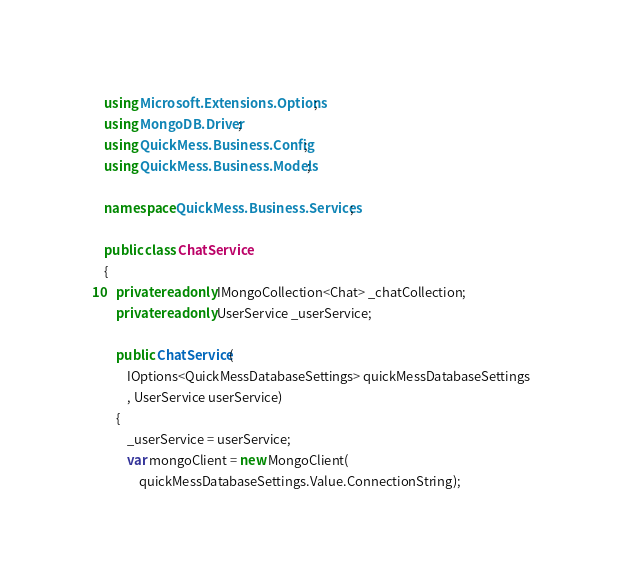Convert code to text. <code><loc_0><loc_0><loc_500><loc_500><_C#_>using Microsoft.Extensions.Options;
using MongoDB.Driver;
using QuickMess.Business.Config;
using QuickMess.Business.Models;

namespace QuickMess.Business.Services;

public class ChatService
{
    private readonly IMongoCollection<Chat> _chatCollection;
    private readonly UserService _userService;

    public ChatService(
        IOptions<QuickMessDatabaseSettings> quickMessDatabaseSettings
        , UserService userService)
    {
        _userService = userService;
        var mongoClient = new MongoClient(
            quickMessDatabaseSettings.Value.ConnectionString);
</code> 